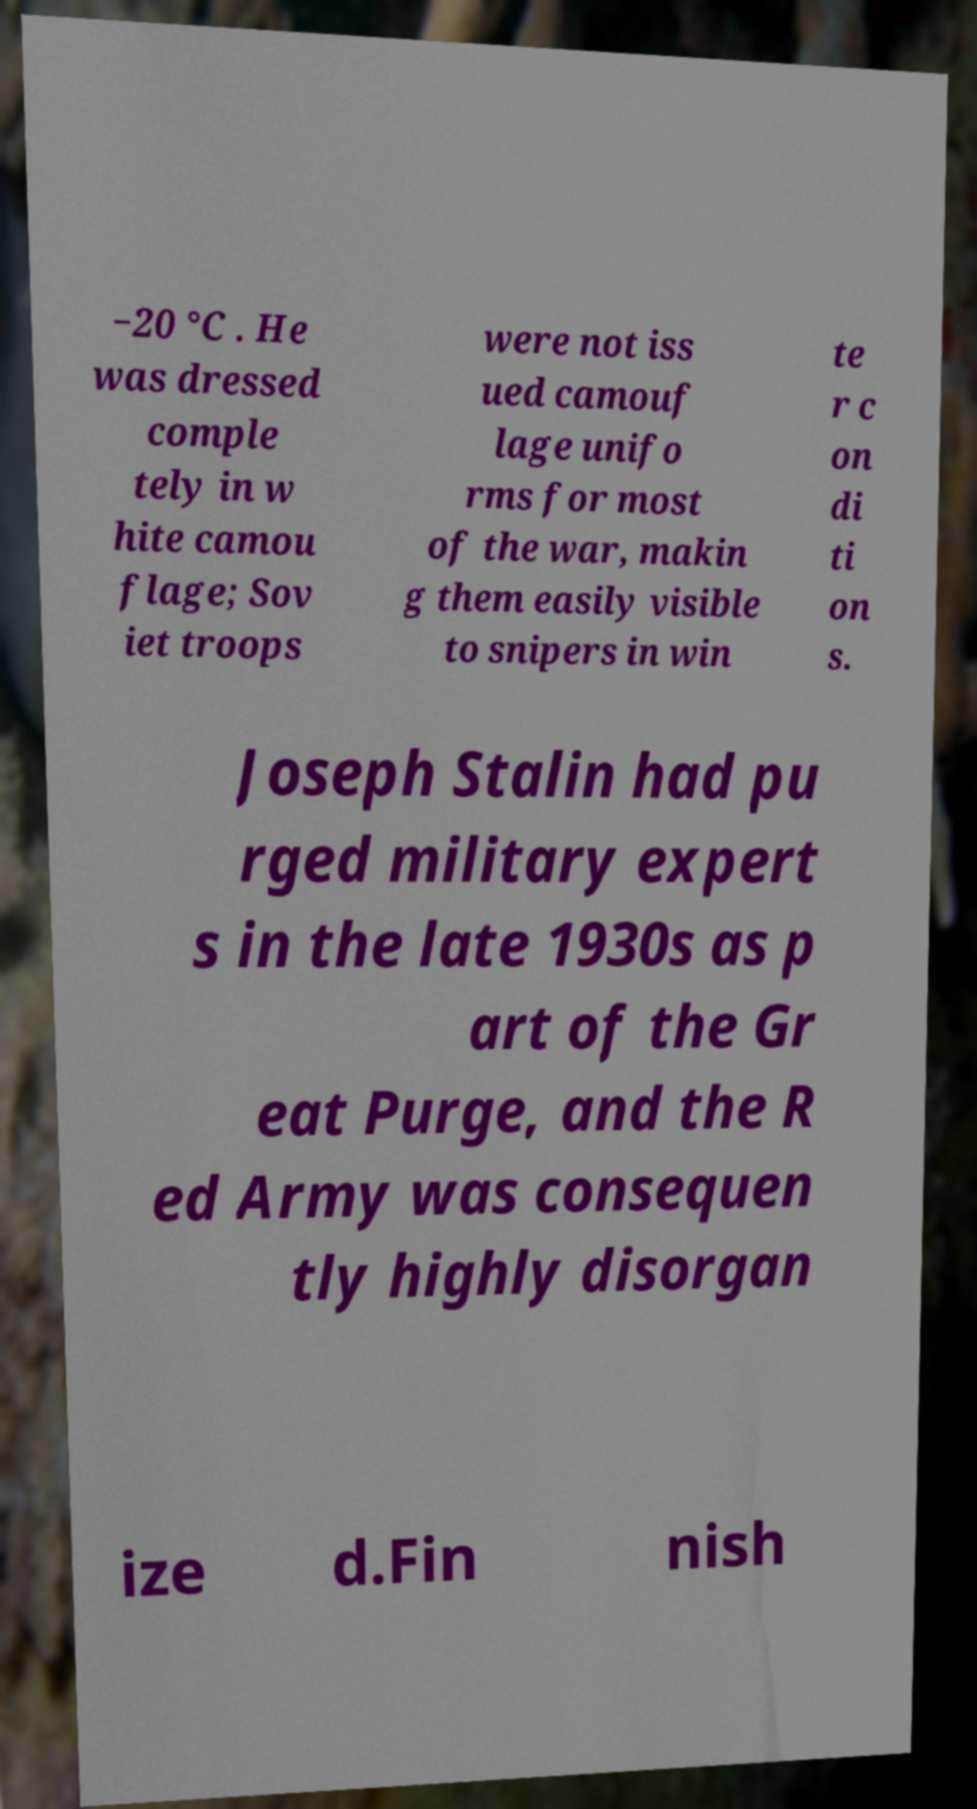Could you assist in decoding the text presented in this image and type it out clearly? −20 °C . He was dressed comple tely in w hite camou flage; Sov iet troops were not iss ued camouf lage unifo rms for most of the war, makin g them easily visible to snipers in win te r c on di ti on s. Joseph Stalin had pu rged military expert s in the late 1930s as p art of the Gr eat Purge, and the R ed Army was consequen tly highly disorgan ize d.Fin nish 